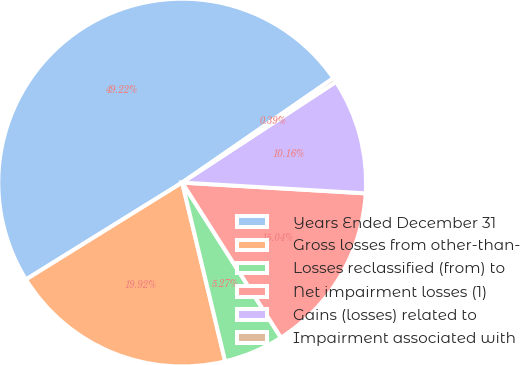Convert chart. <chart><loc_0><loc_0><loc_500><loc_500><pie_chart><fcel>Years Ended December 31<fcel>Gross losses from other-than-<fcel>Losses reclassified (from) to<fcel>Net impairment losses (1)<fcel>Gains (losses) related to<fcel>Impairment associated with<nl><fcel>49.22%<fcel>19.92%<fcel>5.27%<fcel>15.04%<fcel>10.16%<fcel>0.39%<nl></chart> 